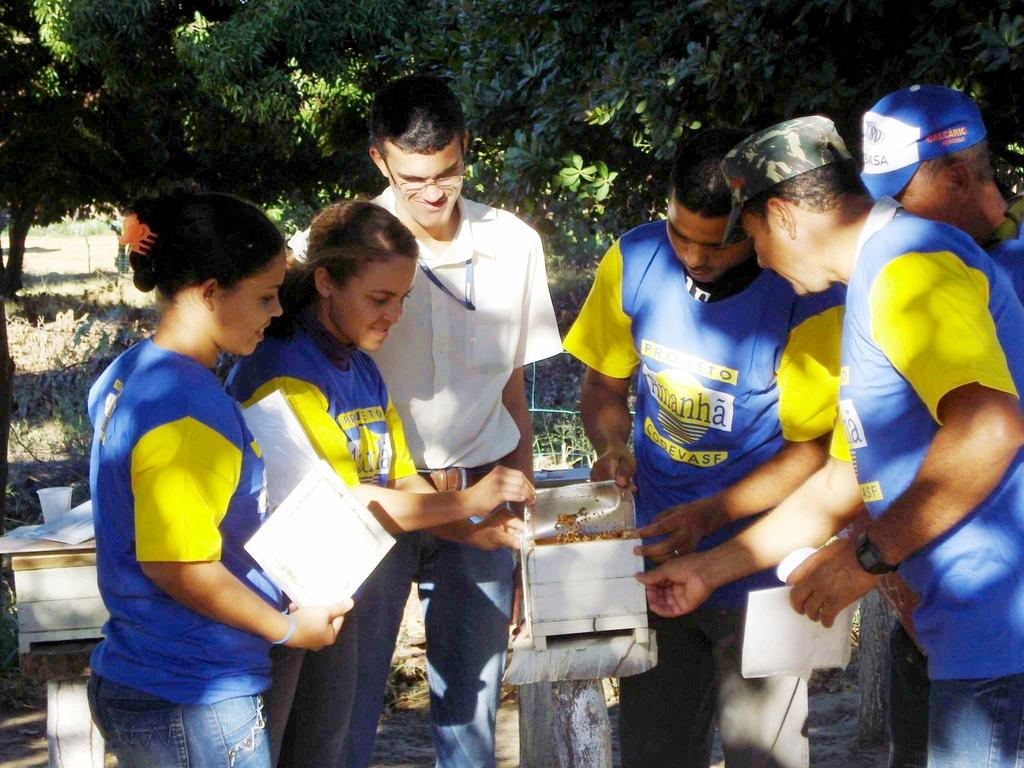What are the people in the image doing? The people in the image are standing. What objects are some people holding in the image? Some people are holding a box, while others are holding papers in their hands. What can be seen in the background of the image? There are trees in the background of the image. What type of zephyr can be seen blowing through the tent in the image? There is no tent or zephyr present in the image. Can you describe the feather that is floating near the people in the image? There is no feather visible in the image. 